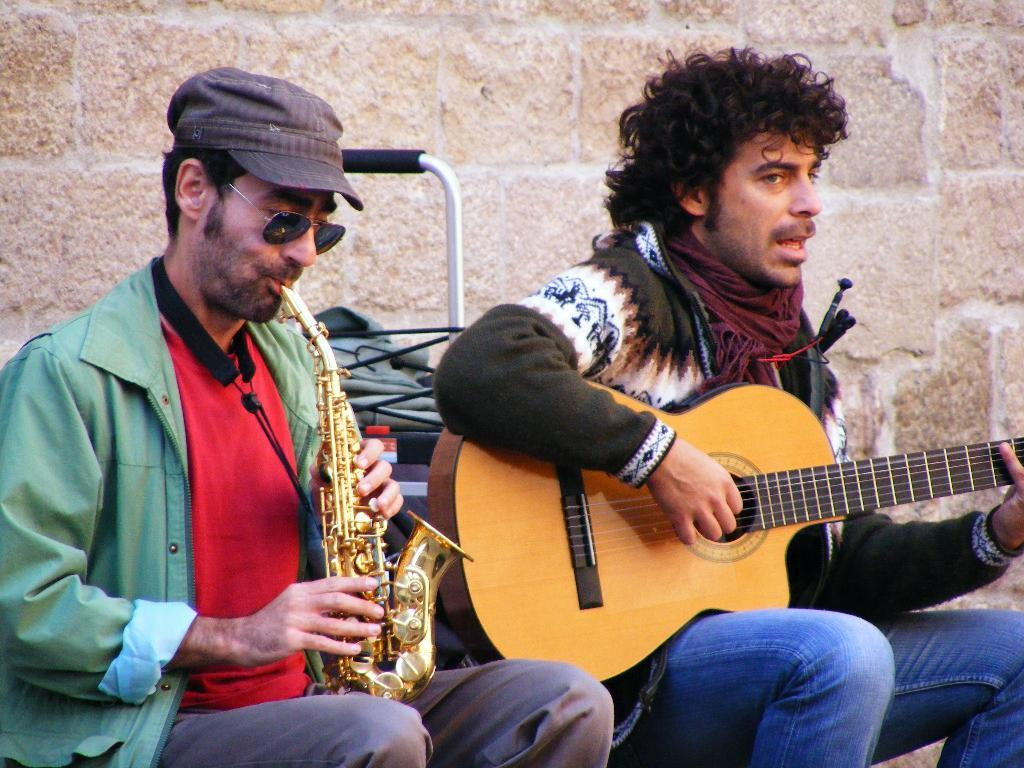How many people are in the image? There are two people in the image. What are the two people doing in the image? The two people are sitting and playing musical instruments. What type of hammer can be seen in the image? There is no hammer present in the image. What language are the two people speaking in the image? The image does not provide any information about the language being spoken by the two people. 